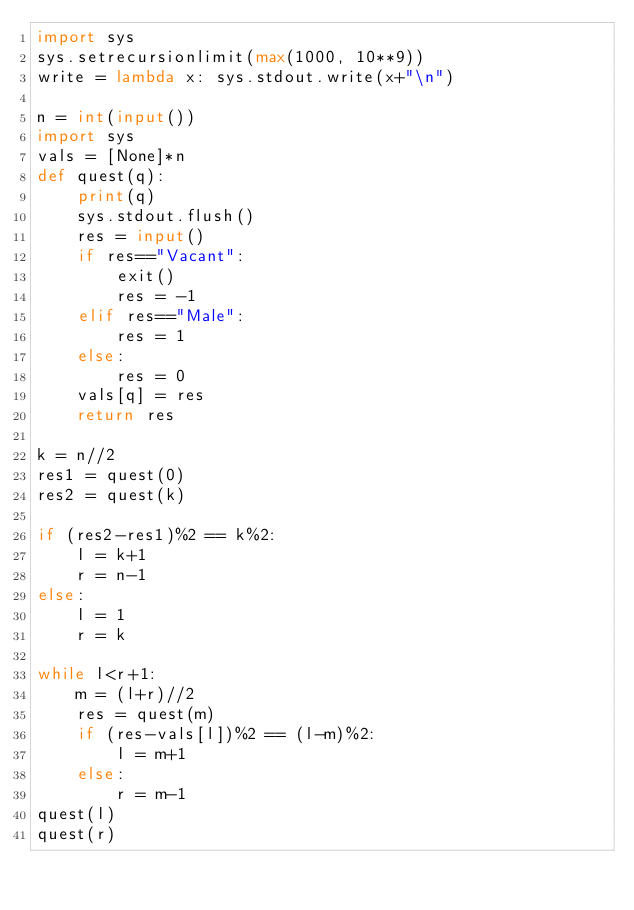Convert code to text. <code><loc_0><loc_0><loc_500><loc_500><_Python_>import sys
sys.setrecursionlimit(max(1000, 10**9))
write = lambda x: sys.stdout.write(x+"\n")

n = int(input())
import sys
vals = [None]*n
def quest(q):
    print(q)
    sys.stdout.flush()
    res = input()
    if res=="Vacant":
        exit()
        res = -1
    elif res=="Male":
        res = 1
    else:
        res = 0
    vals[q] = res
    return res

k = n//2
res1 = quest(0)
res2 = quest(k)

if (res2-res1)%2 == k%2:
    l = k+1
    r = n-1
else:
    l = 1
    r = k
    
while l<r+1:
    m = (l+r)//2
    res = quest(m)
    if (res-vals[l])%2 == (l-m)%2:
        l = m+1
    else:
        r = m-1
quest(l)
quest(r)</code> 